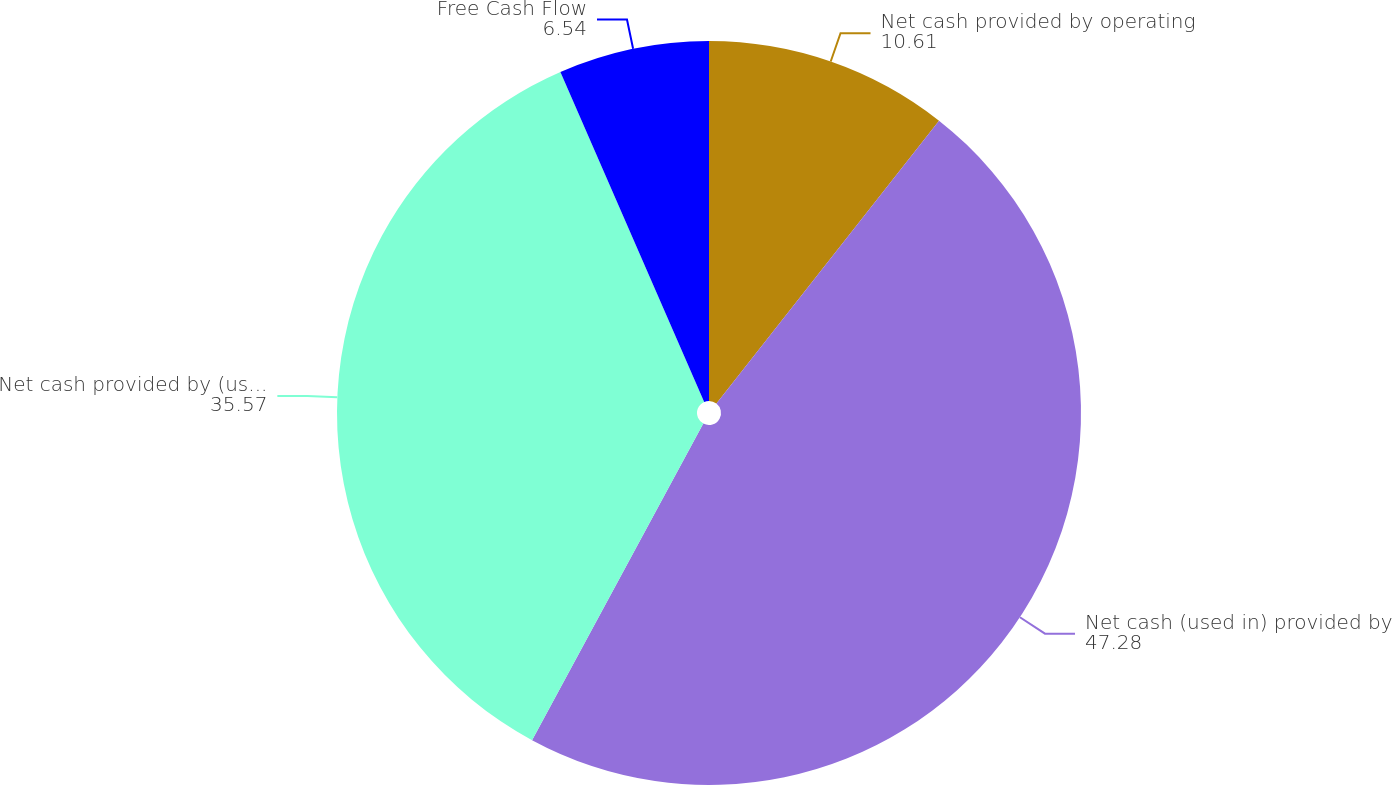Convert chart to OTSL. <chart><loc_0><loc_0><loc_500><loc_500><pie_chart><fcel>Net cash provided by operating<fcel>Net cash (used in) provided by<fcel>Net cash provided by (used in)<fcel>Free Cash Flow<nl><fcel>10.61%<fcel>47.28%<fcel>35.57%<fcel>6.54%<nl></chart> 